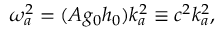<formula> <loc_0><loc_0><loc_500><loc_500>\omega _ { a } ^ { 2 } = ( A g _ { 0 } h _ { 0 } ) k _ { a } ^ { 2 } \equiv c ^ { 2 } k _ { a } ^ { 2 } ,</formula> 